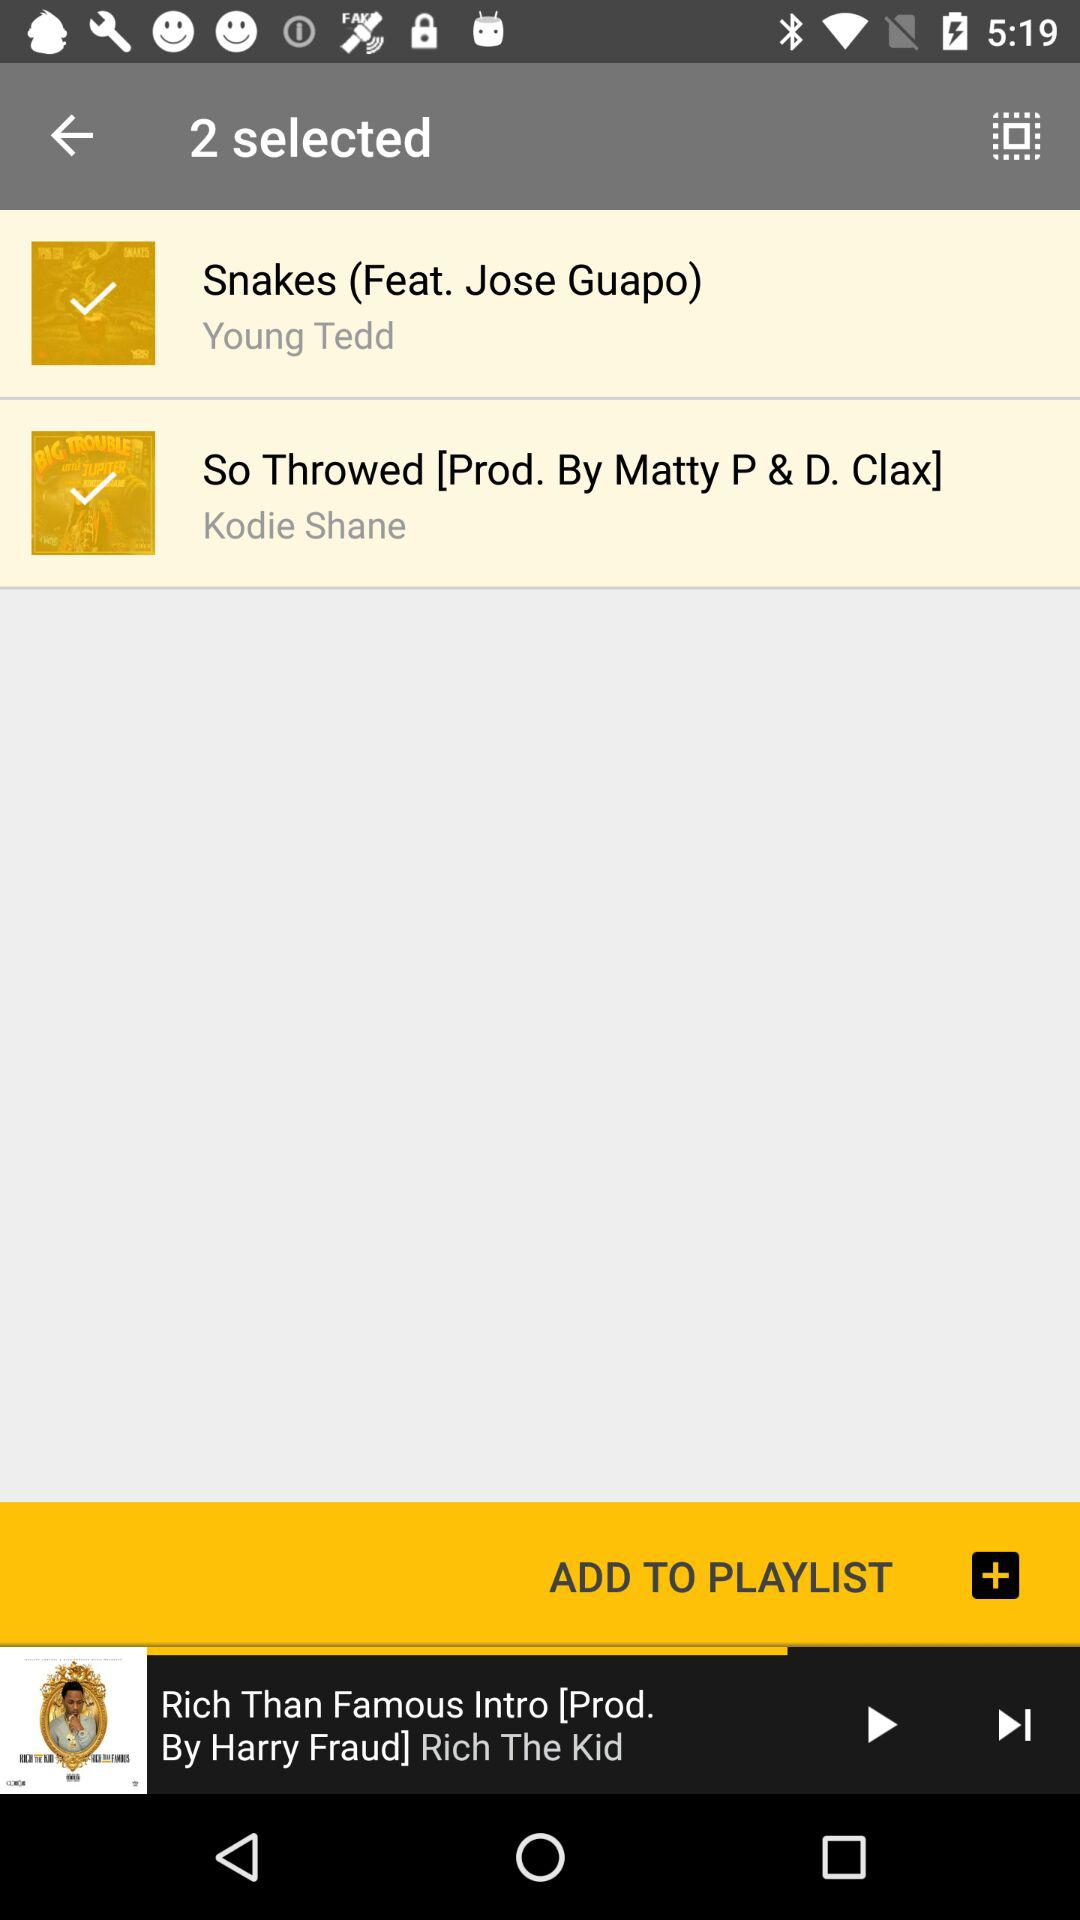What is the total number of selected songs? The number of selected songs is 2. 